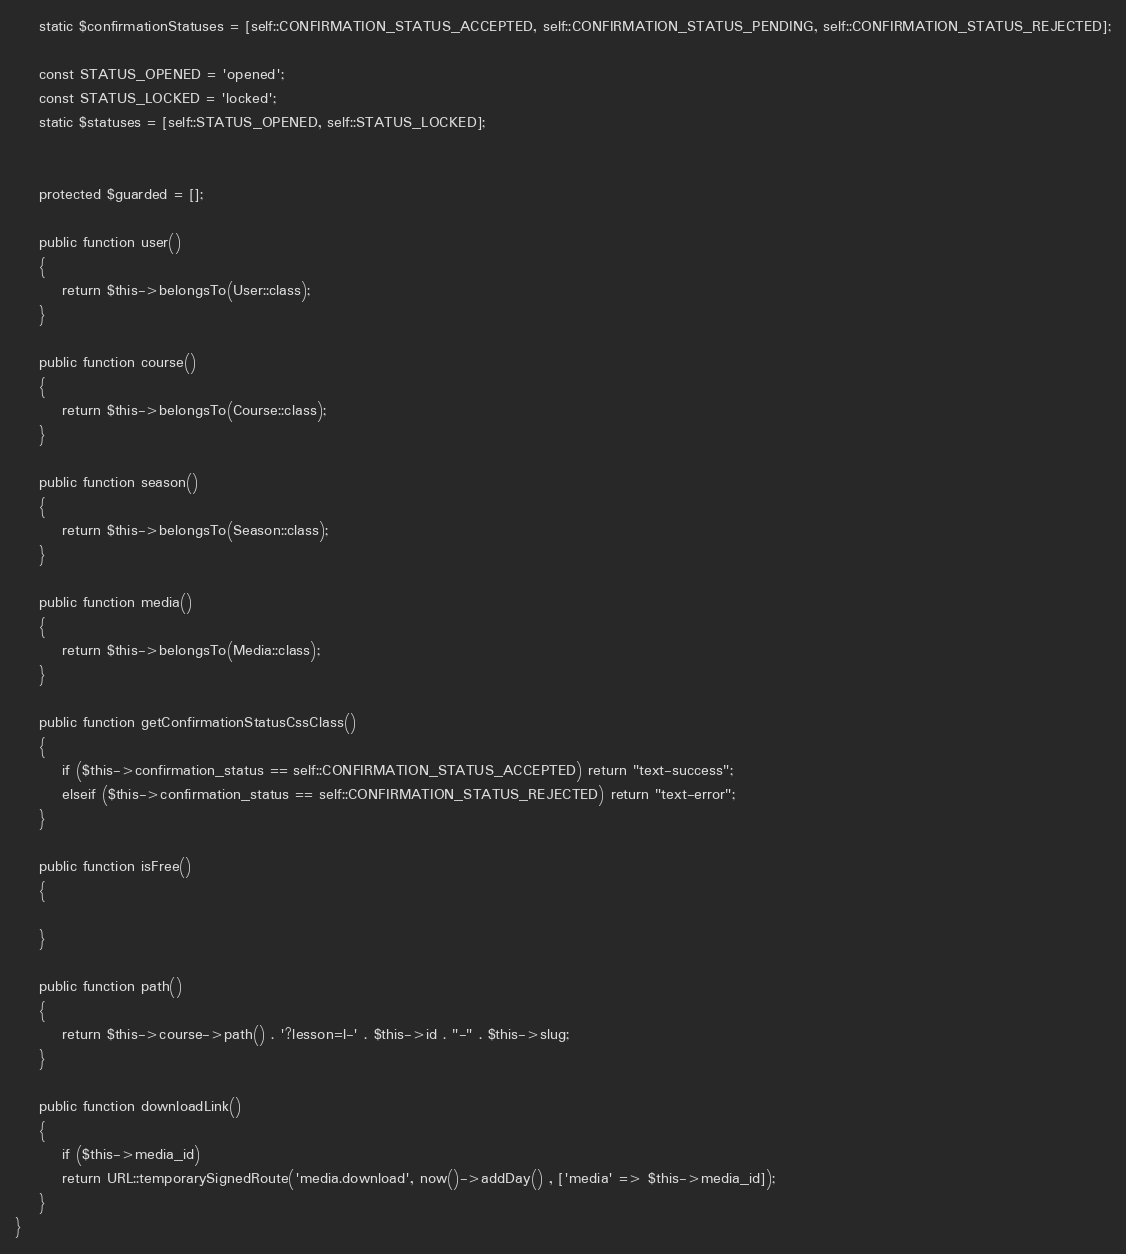<code> <loc_0><loc_0><loc_500><loc_500><_PHP_>    static $confirmationStatuses = [self::CONFIRMATION_STATUS_ACCEPTED, self::CONFIRMATION_STATUS_PENDING, self::CONFIRMATION_STATUS_REJECTED];

    const STATUS_OPENED = 'opened';
    const STATUS_LOCKED = 'locked';
    static $statuses = [self::STATUS_OPENED, self::STATUS_LOCKED];


    protected $guarded = [];

    public function user()
    {
        return $this->belongsTo(User::class);
    }

    public function course()
    {
        return $this->belongsTo(Course::class);
    }

    public function season()
    {
        return $this->belongsTo(Season::class);
    }

    public function media()
    {
        return $this->belongsTo(Media::class);
    }

    public function getConfirmationStatusCssClass()
    {
        if ($this->confirmation_status == self::CONFIRMATION_STATUS_ACCEPTED) return "text-success";
        elseif ($this->confirmation_status == self::CONFIRMATION_STATUS_REJECTED) return "text-error";
    }

    public function isFree()
    {

    }

    public function path()
    {
        return $this->course->path() . '?lesson=l-' . $this->id . "-" . $this->slug;
    }

    public function downloadLink()
    {
        if ($this->media_id)
        return URL::temporarySignedRoute('media.download', now()->addDay() , ['media' => $this->media_id]);
    }
}
</code> 